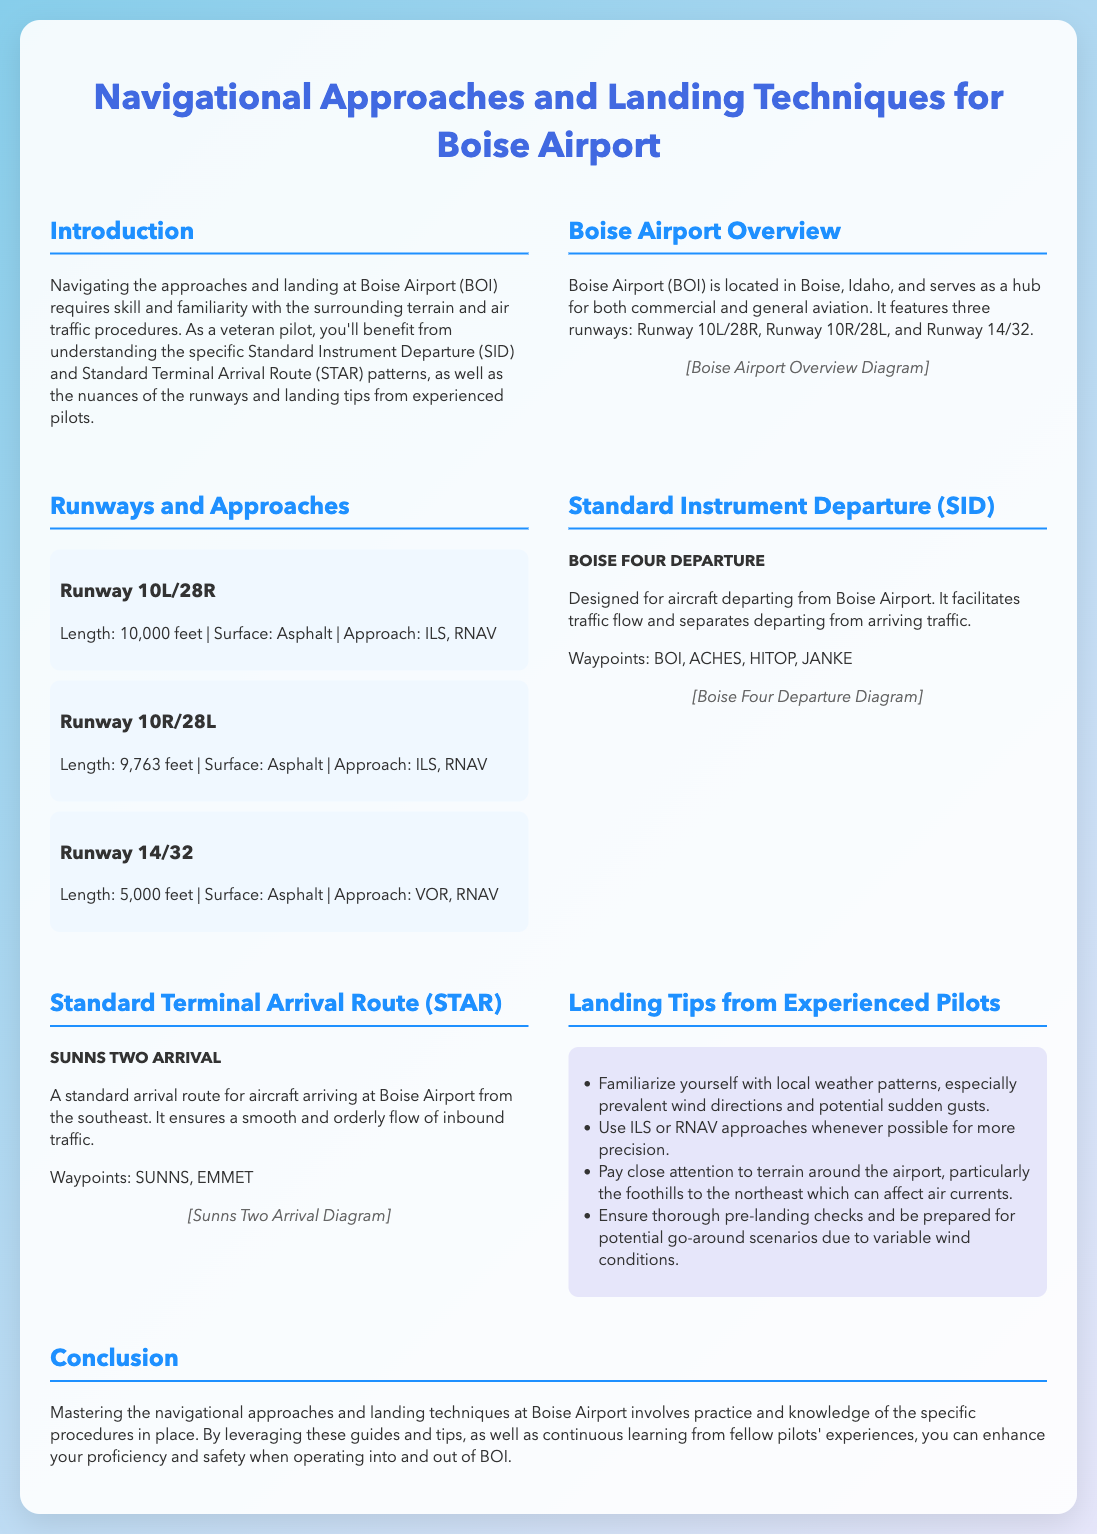What is the location of Boise Airport? The document states that Boise Airport is located in Boise, Idaho.
Answer: Boise, Idaho How many runways does Boise Airport have? The document mentions that Boise Airport features three runways.
Answer: Three What is the length of Runway 10L/28R? The length of Runway 10L/28R is specified in the document as 10,000 feet.
Answer: 10,000 feet What approach types are available for Runway 14/32? The document lists the approach types for Runway 14/32 as VOR and RNAV.
Answer: VOR, RNAV Which departure procedure is mentioned for Boise Airport? The document refers to the BOISE FOUR DEPARTURE for standard instrument departure.
Answer: BOISE FOUR DEPARTURE What are the waypoints for the SUNNS TWO ARRIVAL? The document lists the waypoints for the SUNNS TWO ARRIVAL as SUNNS and EMMET.
Answer: SUNNS, EMMET What surface type do all Boise Airport runways share? The document indicates that all the runways at Boise Airport have an asphalt surface.
Answer: Asphalt Why should pilots be aware of local weather patterns? The document highlights that knowing local weather patterns, particularly winds and gusts, is crucial for landing safety.
Answer: Safety concerns What is a recommended approach type according to landing tips? The document advises the use of ILS or RNAV approaches for precision.
Answer: ILS or RNAV 